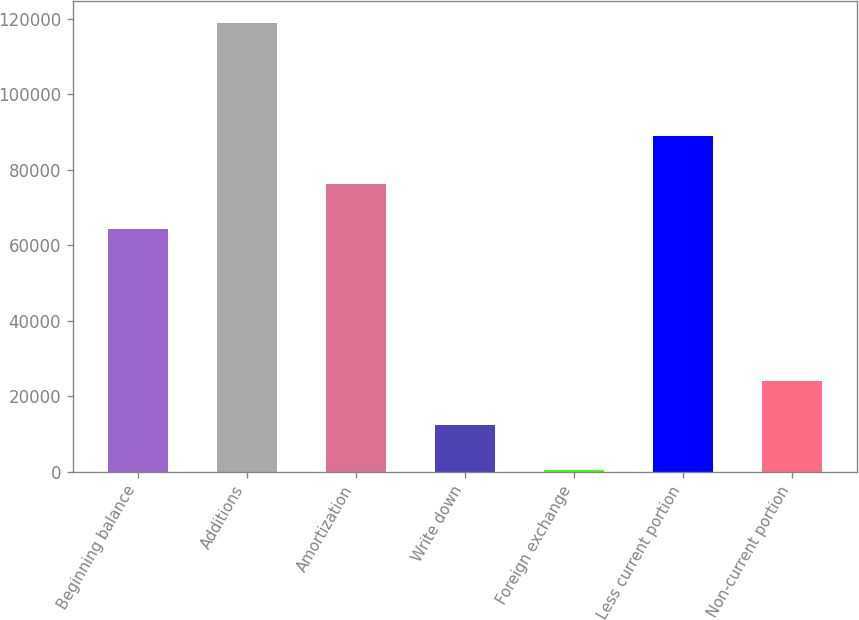Convert chart to OTSL. <chart><loc_0><loc_0><loc_500><loc_500><bar_chart><fcel>Beginning balance<fcel>Additions<fcel>Amortization<fcel>Write down<fcel>Foreign exchange<fcel>Less current portion<fcel>Non-current portion<nl><fcel>64322<fcel>118711<fcel>76156.6<fcel>12199.6<fcel>365<fcel>88826<fcel>24034.2<nl></chart> 